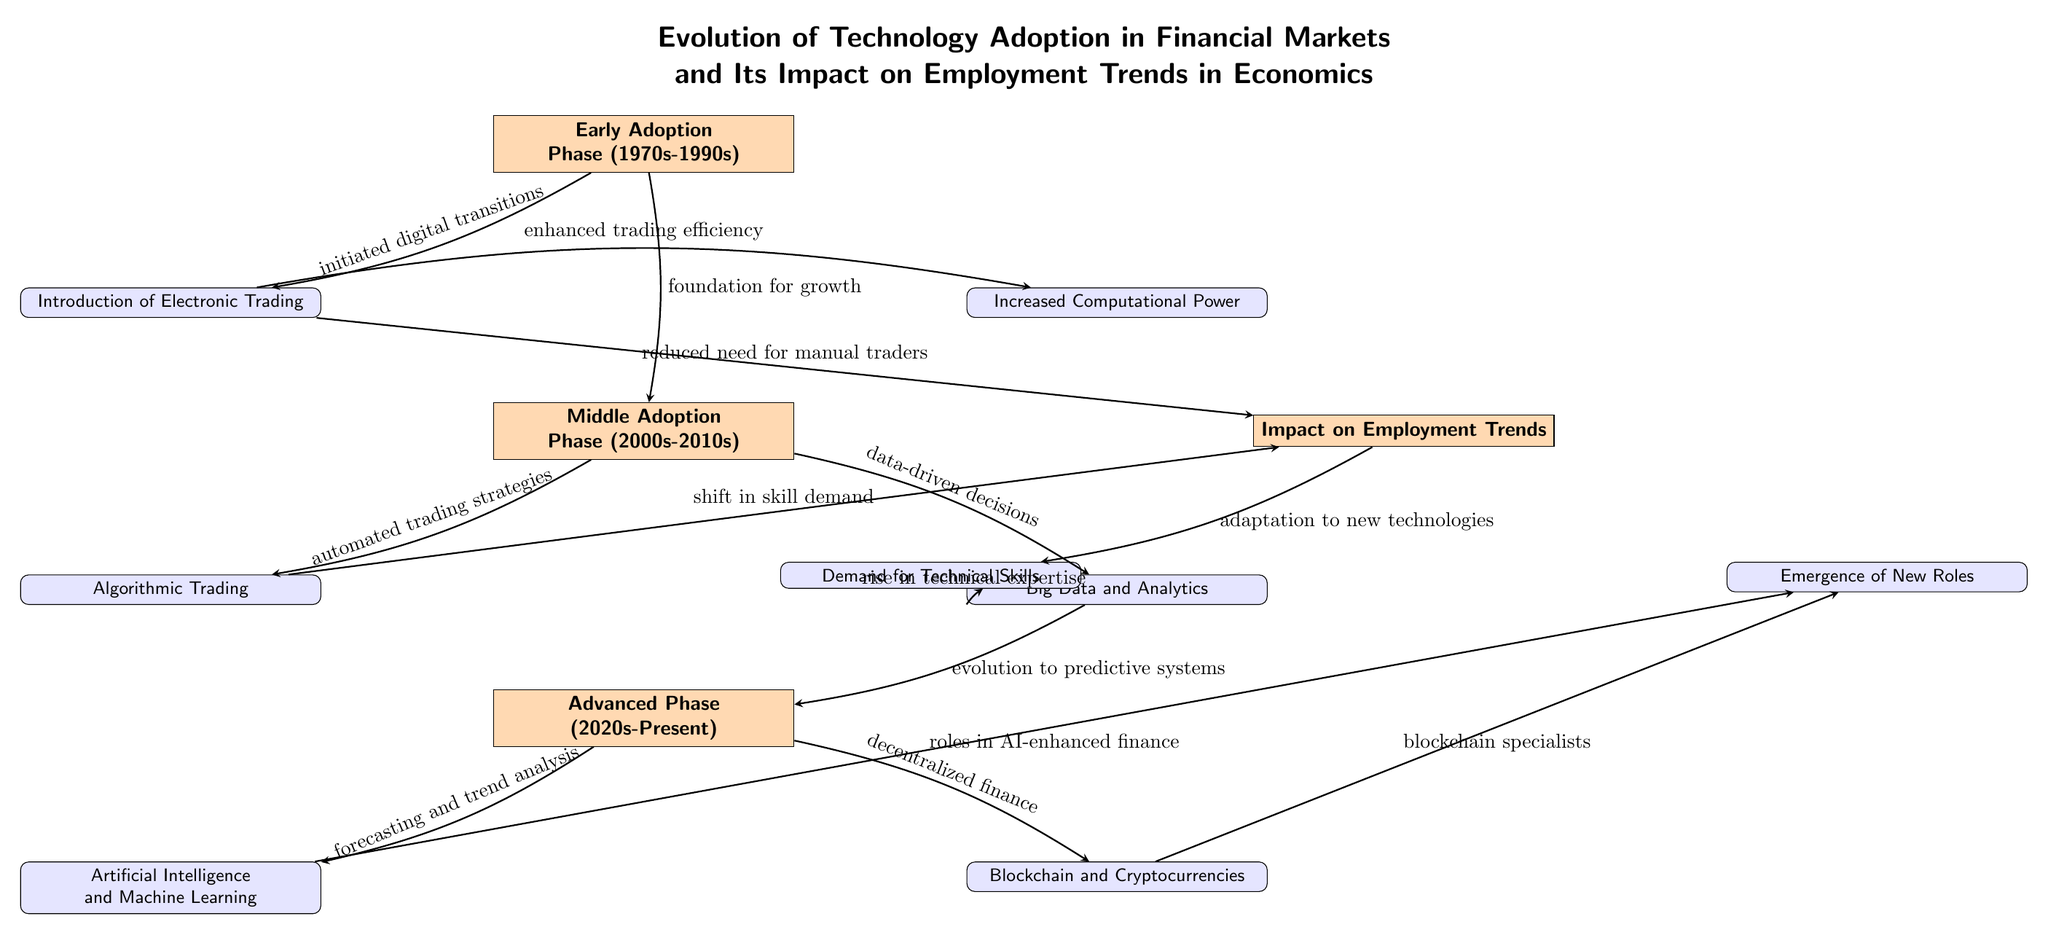What is the first phase of technology adoption shown in the diagram? The diagram indicates that the first phase of technology adoption is labeled as "Early Adoption Phase (1970s-1990s)". This is identified as the topmost node in the diagram.
Answer: Early Adoption Phase (1970s-1990s) What are the two nodes related to the Middle Adoption Phase? The Middle Adoption Phase node branches into two specific nodes: "Algorithmic Trading" and "Big Data and Analytics". These are positioned directly below the Middle Adoption Phase node in the diagram.
Answer: Algorithmic Trading, Big Data and Analytics Which technology is associated with the Advanced Phase? In the diagram, the Advanced Phase is linked to "Artificial Intelligence and Machine Learning" and "Blockchain and Cryptocurrencies". These nodes demonstrate the current advancements detailed in the Advanced Phase.
Answer: Artificial Intelligence and Machine Learning, Blockchain and Cryptocurrencies How does the Early Adoption Phase influence employment trends? The Early Adoption Phase affects employment trends through the edge that states "reduced need for manual traders", indicating that as technology evolved in this phase, the demand for traditional roles in trading diminished.
Answer: Reduced need for manual traders What impacts does increased computational power have in this diagram? Increased computational power connects to the development of "Big Data and Analytics" and is situated below the Early Adoption Phase. This highlights that this technology enhances data utilization leading to more analytic capabilities in trading.
Answer: Big Data and Analytics During which phase does the evolution to predictive systems occur? The evolution to predictive systems occurs in the Advanced Phase (2020s-Present). The diagram indicates a flow from "Big Data and Analytics" to this phase, signifying advancements in predictive technologies during this period.
Answer: Advanced Phase (2020s-Present) Which two factors contribute to the demand for technical skills depicted in the diagram? The diagram shows that "Rise in technical expertise" and "Adaptation to new technologies" significantly contribute to the demand for technical skills. Both these factors are connected to the Impact on Employment Trends section of the diagram.
Answer: Rise in technical expertise, Adaptation to new technologies What is the relationship between algorithmic trading and employment trends? The relationship depicted in the diagram indicates that algorithmic trading leads to a "shift in skill demand," indicating that as algorithmic trading becomes prevalent, the nature of skills required in the workforce changes as well.
Answer: Shift in skill demand 